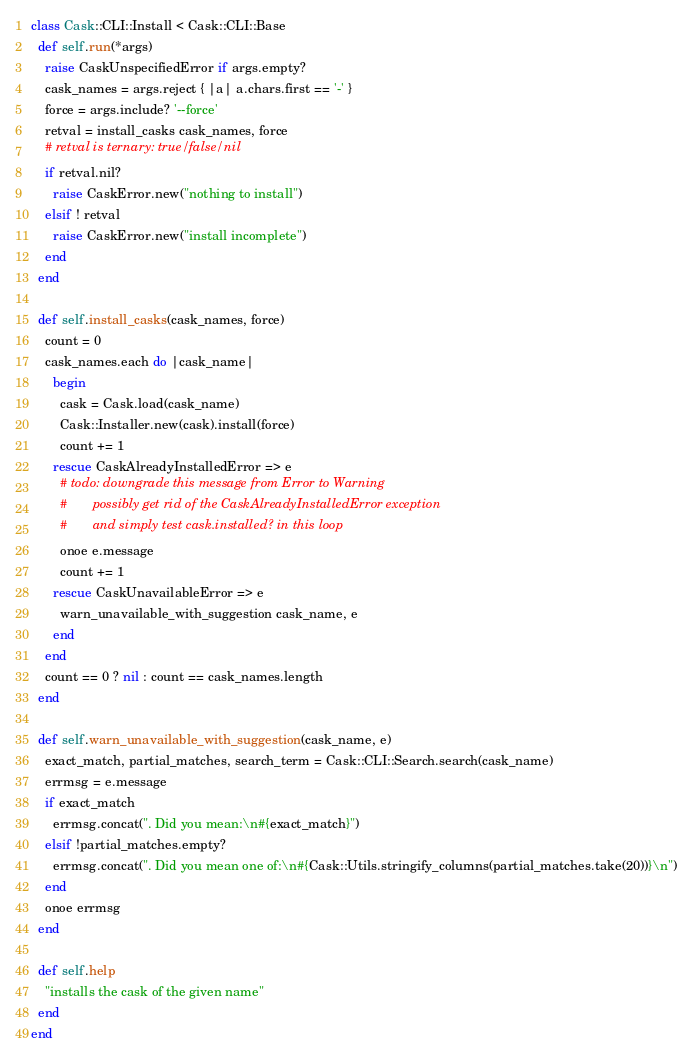<code> <loc_0><loc_0><loc_500><loc_500><_Ruby_>class Cask::CLI::Install < Cask::CLI::Base
  def self.run(*args)
    raise CaskUnspecifiedError if args.empty?
    cask_names = args.reject { |a| a.chars.first == '-' }
    force = args.include? '--force'
    retval = install_casks cask_names, force
    # retval is ternary: true/false/nil
    if retval.nil?
      raise CaskError.new("nothing to install")
    elsif ! retval
      raise CaskError.new("install incomplete")
    end
  end

  def self.install_casks(cask_names, force)
    count = 0
    cask_names.each do |cask_name|
      begin
        cask = Cask.load(cask_name)
        Cask::Installer.new(cask).install(force)
        count += 1
      rescue CaskAlreadyInstalledError => e
        # todo: downgrade this message from Error to Warning
        #       possibly get rid of the CaskAlreadyInstalledError exception
        #       and simply test cask.installed? in this loop
        onoe e.message
        count += 1
      rescue CaskUnavailableError => e
        warn_unavailable_with_suggestion cask_name, e
      end
    end
    count == 0 ? nil : count == cask_names.length
  end

  def self.warn_unavailable_with_suggestion(cask_name, e)
    exact_match, partial_matches, search_term = Cask::CLI::Search.search(cask_name)
    errmsg = e.message
    if exact_match
      errmsg.concat(". Did you mean:\n#{exact_match}")
    elsif !partial_matches.empty?
      errmsg.concat(". Did you mean one of:\n#{Cask::Utils.stringify_columns(partial_matches.take(20))}\n")
    end
    onoe errmsg
  end

  def self.help
    "installs the cask of the given name"
  end
end
</code> 